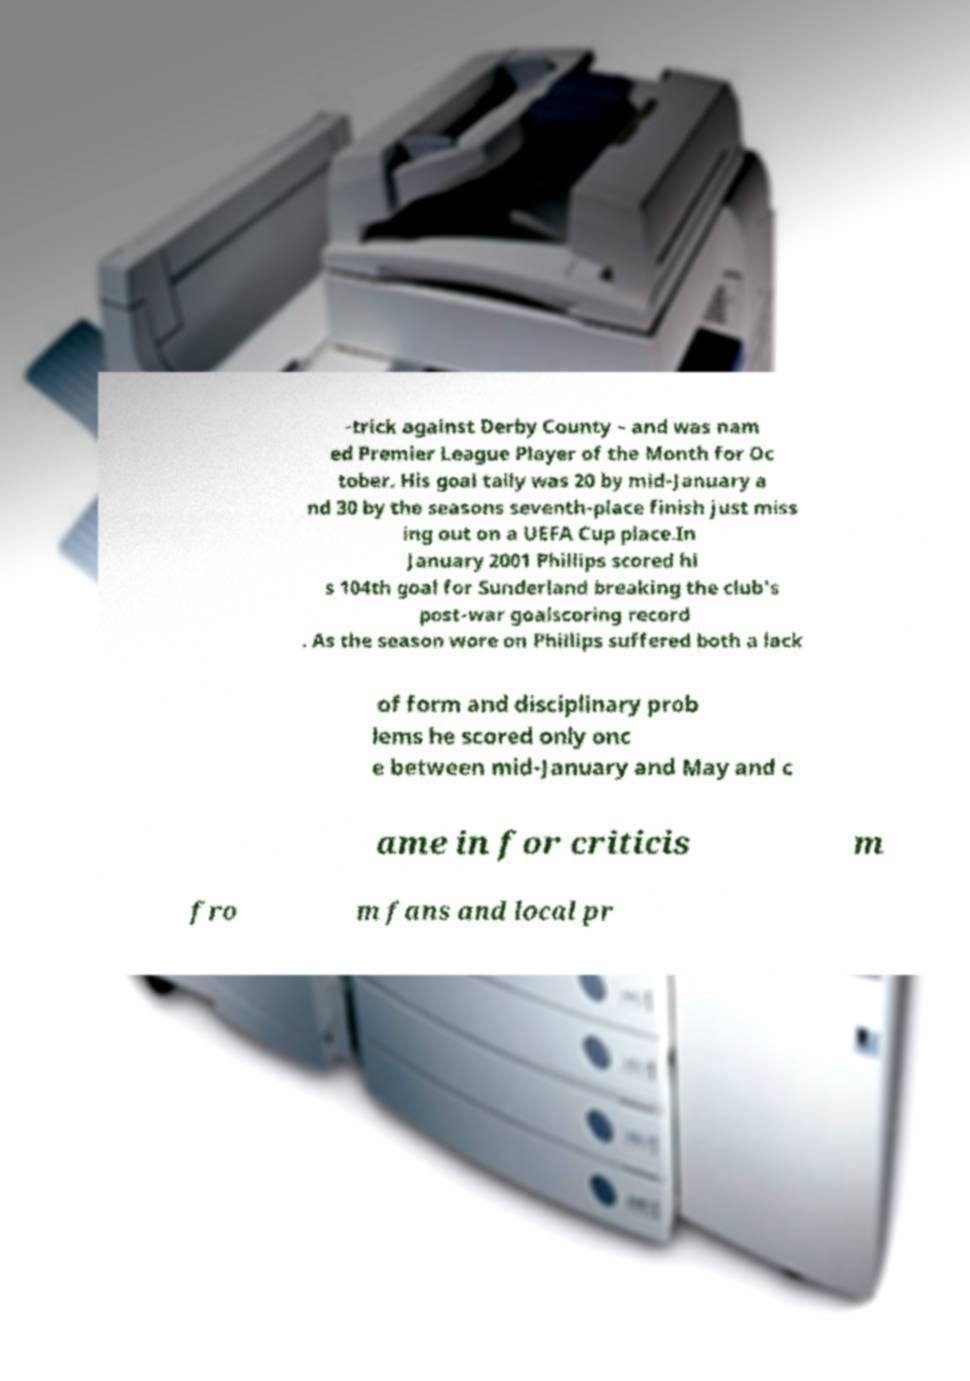Can you accurately transcribe the text from the provided image for me? -trick against Derby County – and was nam ed Premier League Player of the Month for Oc tober. His goal tally was 20 by mid-January a nd 30 by the seasons seventh-place finish just miss ing out on a UEFA Cup place.In January 2001 Phillips scored hi s 104th goal for Sunderland breaking the club's post-war goalscoring record . As the season wore on Phillips suffered both a lack of form and disciplinary prob lems he scored only onc e between mid-January and May and c ame in for criticis m fro m fans and local pr 